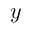<formula> <loc_0><loc_0><loc_500><loc_500>y</formula> 